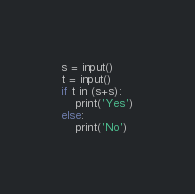<code> <loc_0><loc_0><loc_500><loc_500><_Python_>s = input()
t = input()
if t in (s+s):
    print('Yes')
else:
    print('No')
</code> 